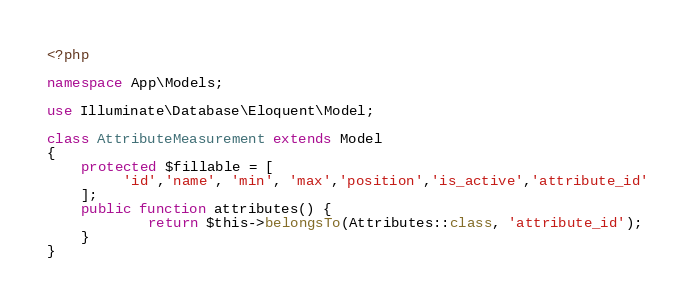Convert code to text. <code><loc_0><loc_0><loc_500><loc_500><_PHP_><?php

namespace App\Models;

use Illuminate\Database\Eloquent\Model;

class AttributeMeasurement extends Model
{
    protected $fillable = [
         'id','name', 'min', 'max','position','is_active','attribute_id'
    ];
    public function attributes() {
            return $this->belongsTo(Attributes::class, 'attribute_id');
    }
}
</code> 